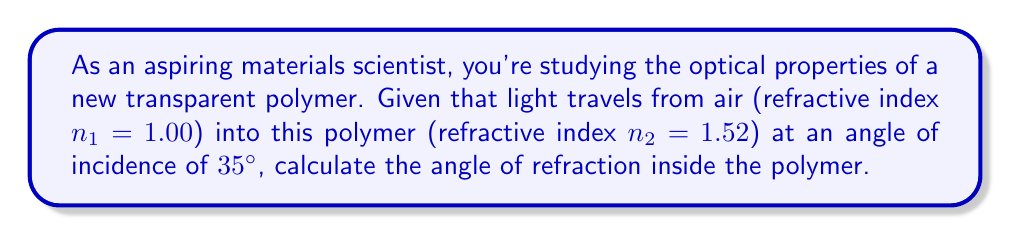Can you answer this question? To solve this problem, we'll use Snell's Law, which describes the relationship between the angles of incidence and refraction for light passing through different materials:

$$n_1 \sin(\theta_1) = n_2 \sin(\theta_2)$$

Where:
$n_1$ = refractive index of the first medium (air)
$n_2$ = refractive index of the second medium (polymer)
$\theta_1$ = angle of incidence
$\theta_2$ = angle of refraction (what we're solving for)

Given:
$n_1 = 1.00$
$n_2 = 1.52$
$\theta_1 = 35°$

Step 1: Substitute the known values into Snell's Law:
$$(1.00) \sin(35°) = (1.52) \sin(\theta_2)$$

Step 2: Isolate $\sin(\theta_2)$:
$$\sin(\theta_2) = \frac{(1.00) \sin(35°)}{1.52}$$

Step 3: Calculate the right-hand side:
$$\sin(\theta_2) = \frac{1.00 \times 0.5736}{1.52} = 0.3774$$

Step 4: Take the inverse sine (arcsin) of both sides to solve for $\theta_2$:
$$\theta_2 = \arcsin(0.3774)$$

Step 5: Calculate the final result:
$$\theta_2 \approx 22.16°$$

Therefore, the angle of refraction inside the polymer is approximately 22.16°.
Answer: $22.16°$ 